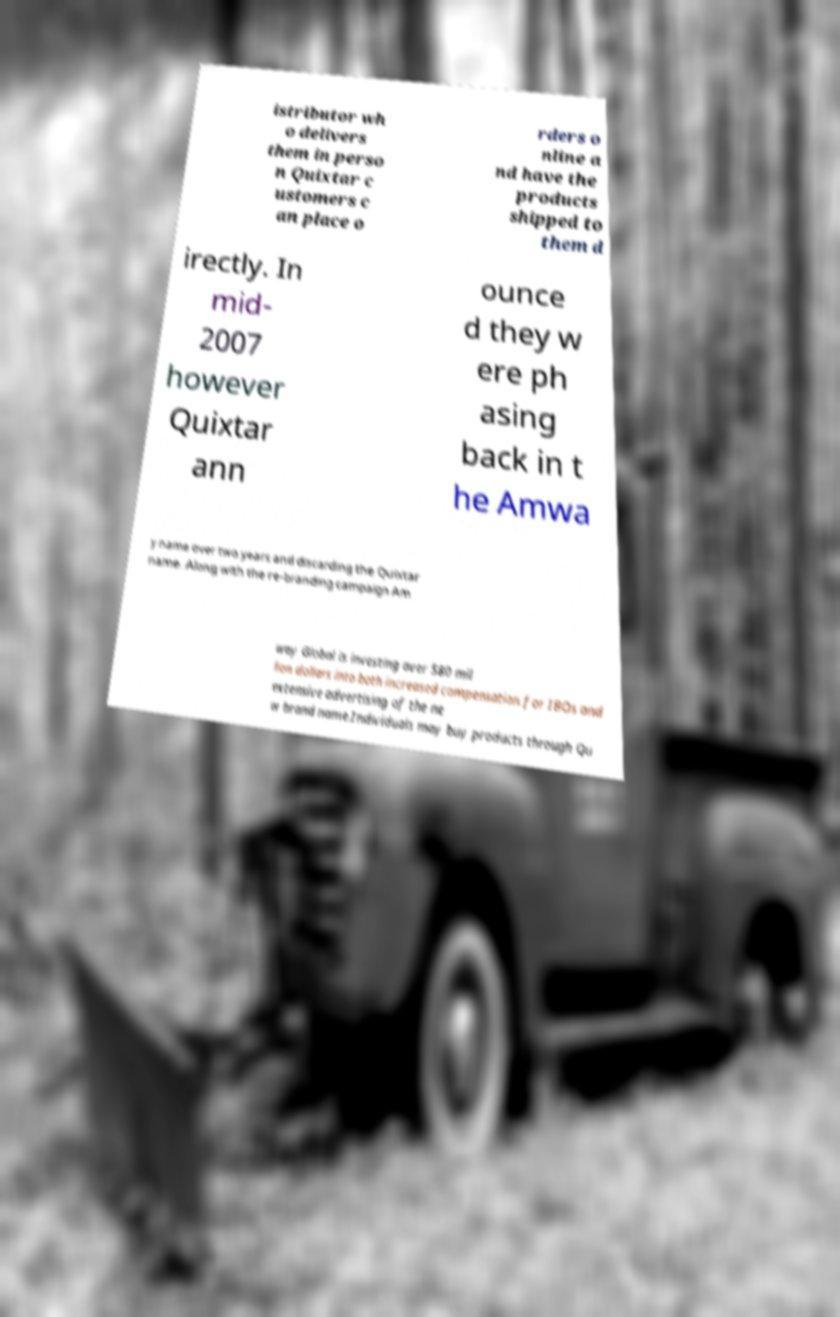Could you extract and type out the text from this image? istributor wh o delivers them in perso n Quixtar c ustomers c an place o rders o nline a nd have the products shipped to them d irectly. In mid- 2007 however Quixtar ann ounce d they w ere ph asing back in t he Amwa y name over two years and discarding the Quixtar name. Along with the re-branding campaign Am way Global is investing over 580 mil lion dollars into both increased compensation for IBOs and extensive advertising of the ne w brand name.Individuals may buy products through Qu 